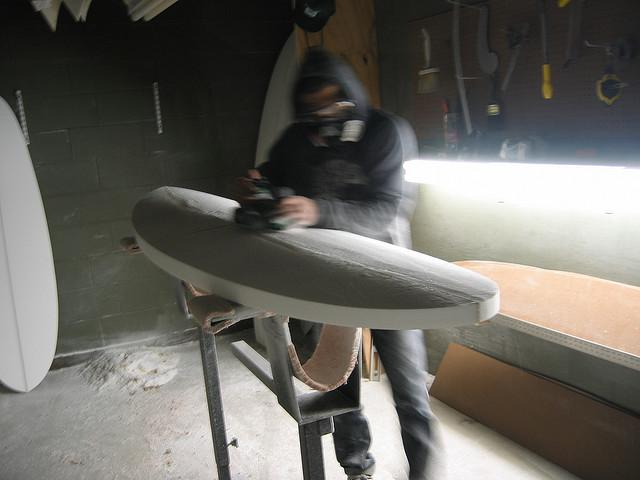What is the man wearing on his head?

Choices:
A) helmet
B) hat
C) glasses
D) hood hood 